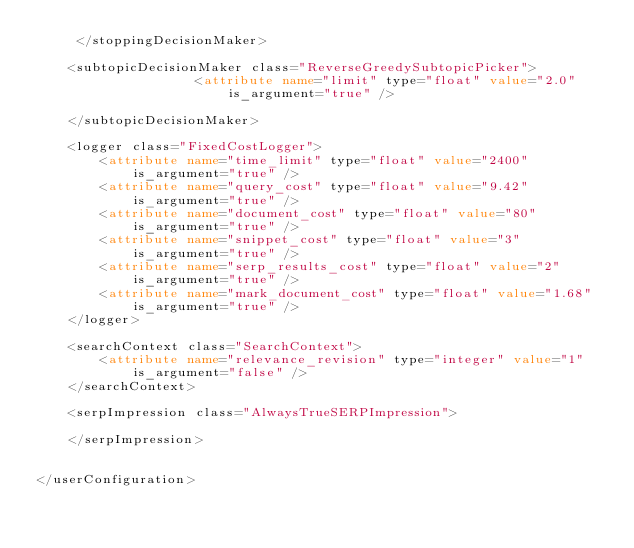Convert code to text. <code><loc_0><loc_0><loc_500><loc_500><_XML_>     </stoppingDecisionMaker>

    <subtopicDecisionMaker class="ReverseGreedySubtopicPicker">
                    <attribute name="limit" type="float" value="2.0" is_argument="true" />

    </subtopicDecisionMaker>

    <logger class="FixedCostLogger">
		<attribute name="time_limit" type="float" value="2400" is_argument="true" />
		<attribute name="query_cost" type="float" value="9.42" is_argument="true" />
		<attribute name="document_cost" type="float" value="80" is_argument="true" />
		<attribute name="snippet_cost" type="float" value="3" is_argument="true" />
		<attribute name="serp_results_cost" type="float" value="2" is_argument="true" />
		<attribute name="mark_document_cost" type="float" value="1.68" is_argument="true" />
	</logger>

	<searchContext class="SearchContext">
		<attribute name="relevance_revision" type="integer" value="1" is_argument="false" />
	</searchContext>

	<serpImpression class="AlwaysTrueSERPImpression">
        
	</serpImpression>


</userConfiguration></code> 